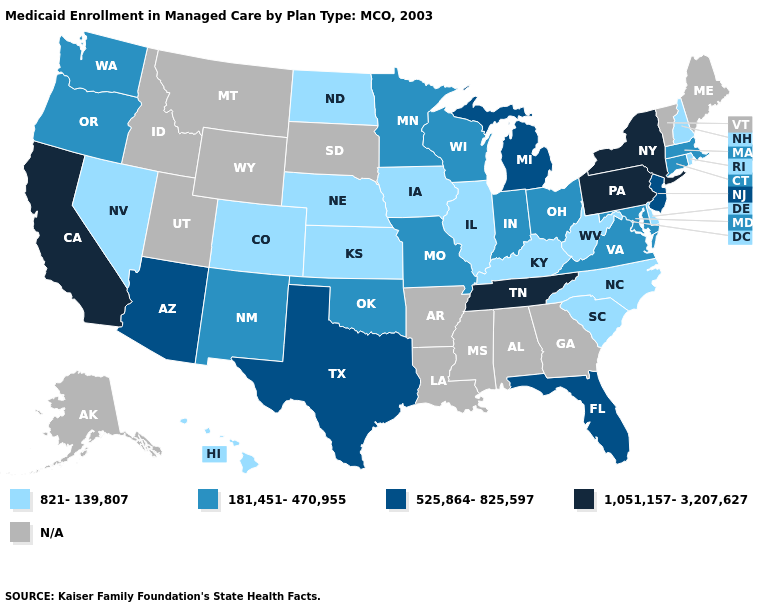What is the highest value in the USA?
Be succinct. 1,051,157-3,207,627. What is the lowest value in states that border Idaho?
Keep it brief. 821-139,807. Does the first symbol in the legend represent the smallest category?
Concise answer only. Yes. What is the lowest value in states that border Connecticut?
Quick response, please. 821-139,807. Name the states that have a value in the range N/A?
Short answer required. Alabama, Alaska, Arkansas, Georgia, Idaho, Louisiana, Maine, Mississippi, Montana, South Dakota, Utah, Vermont, Wyoming. What is the lowest value in the West?
Short answer required. 821-139,807. What is the value of Ohio?
Write a very short answer. 181,451-470,955. Does the map have missing data?
Keep it brief. Yes. What is the value of Louisiana?
Short answer required. N/A. Does California have the highest value in the USA?
Concise answer only. Yes. Name the states that have a value in the range 821-139,807?
Be succinct. Colorado, Delaware, Hawaii, Illinois, Iowa, Kansas, Kentucky, Nebraska, Nevada, New Hampshire, North Carolina, North Dakota, Rhode Island, South Carolina, West Virginia. What is the value of Massachusetts?
Be succinct. 181,451-470,955. Does Pennsylvania have the highest value in the USA?
Give a very brief answer. Yes. 